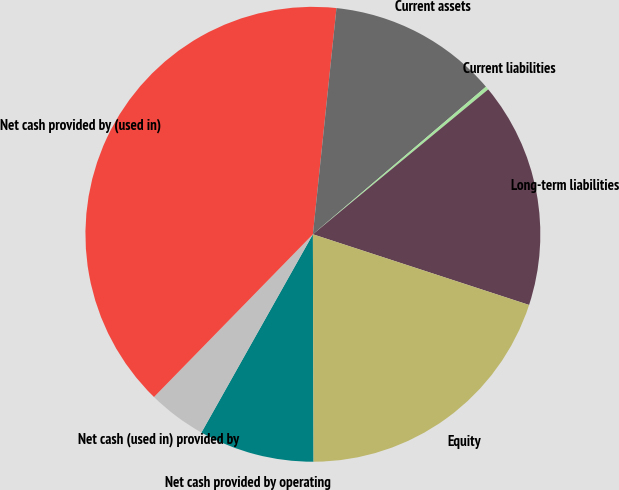Convert chart to OTSL. <chart><loc_0><loc_0><loc_500><loc_500><pie_chart><fcel>Net cash provided by operating<fcel>Net cash (used in) provided by<fcel>Net cash provided by (used in)<fcel>Current assets<fcel>Current liabilities<fcel>Long-term liabilities<fcel>Equity<nl><fcel>8.2%<fcel>4.16%<fcel>39.35%<fcel>12.11%<fcel>0.25%<fcel>16.02%<fcel>19.93%<nl></chart> 